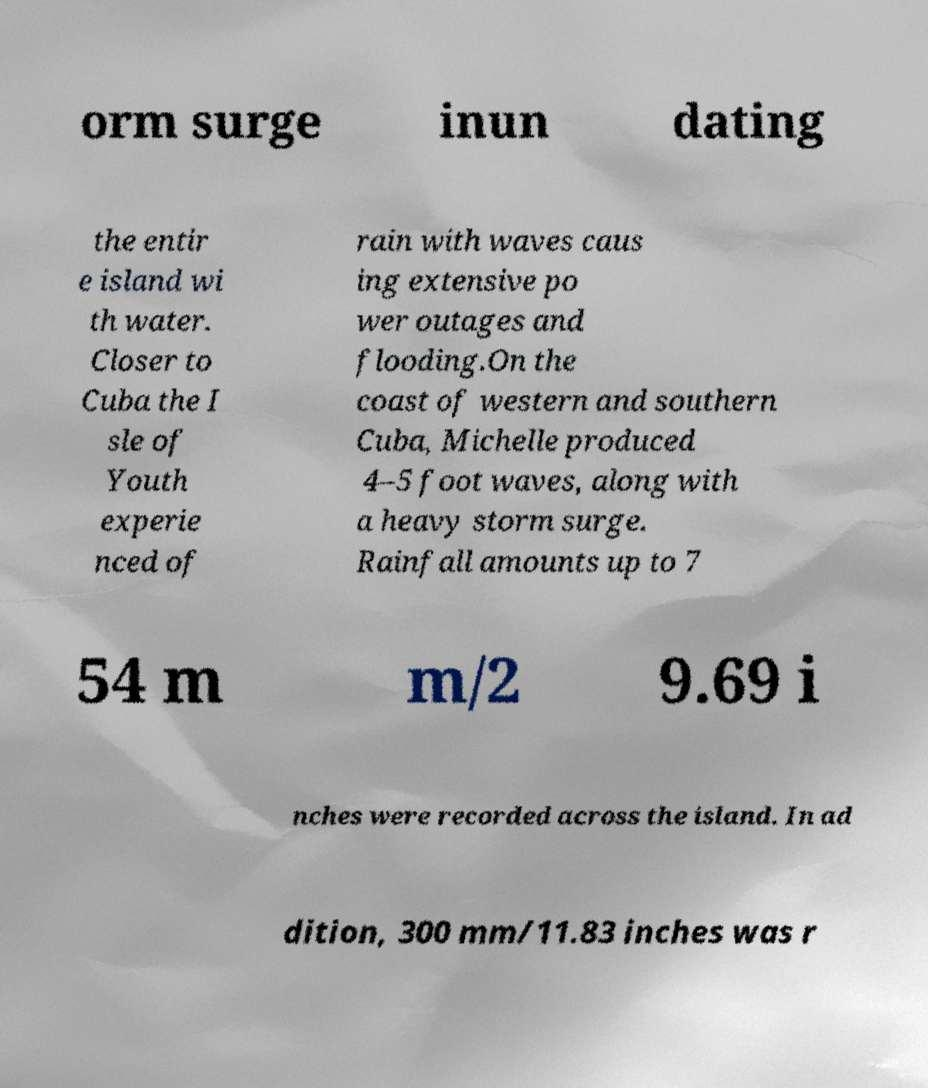Could you extract and type out the text from this image? orm surge inun dating the entir e island wi th water. Closer to Cuba the I sle of Youth experie nced of rain with waves caus ing extensive po wer outages and flooding.On the coast of western and southern Cuba, Michelle produced 4–5 foot waves, along with a heavy storm surge. Rainfall amounts up to 7 54 m m/2 9.69 i nches were recorded across the island. In ad dition, 300 mm/11.83 inches was r 